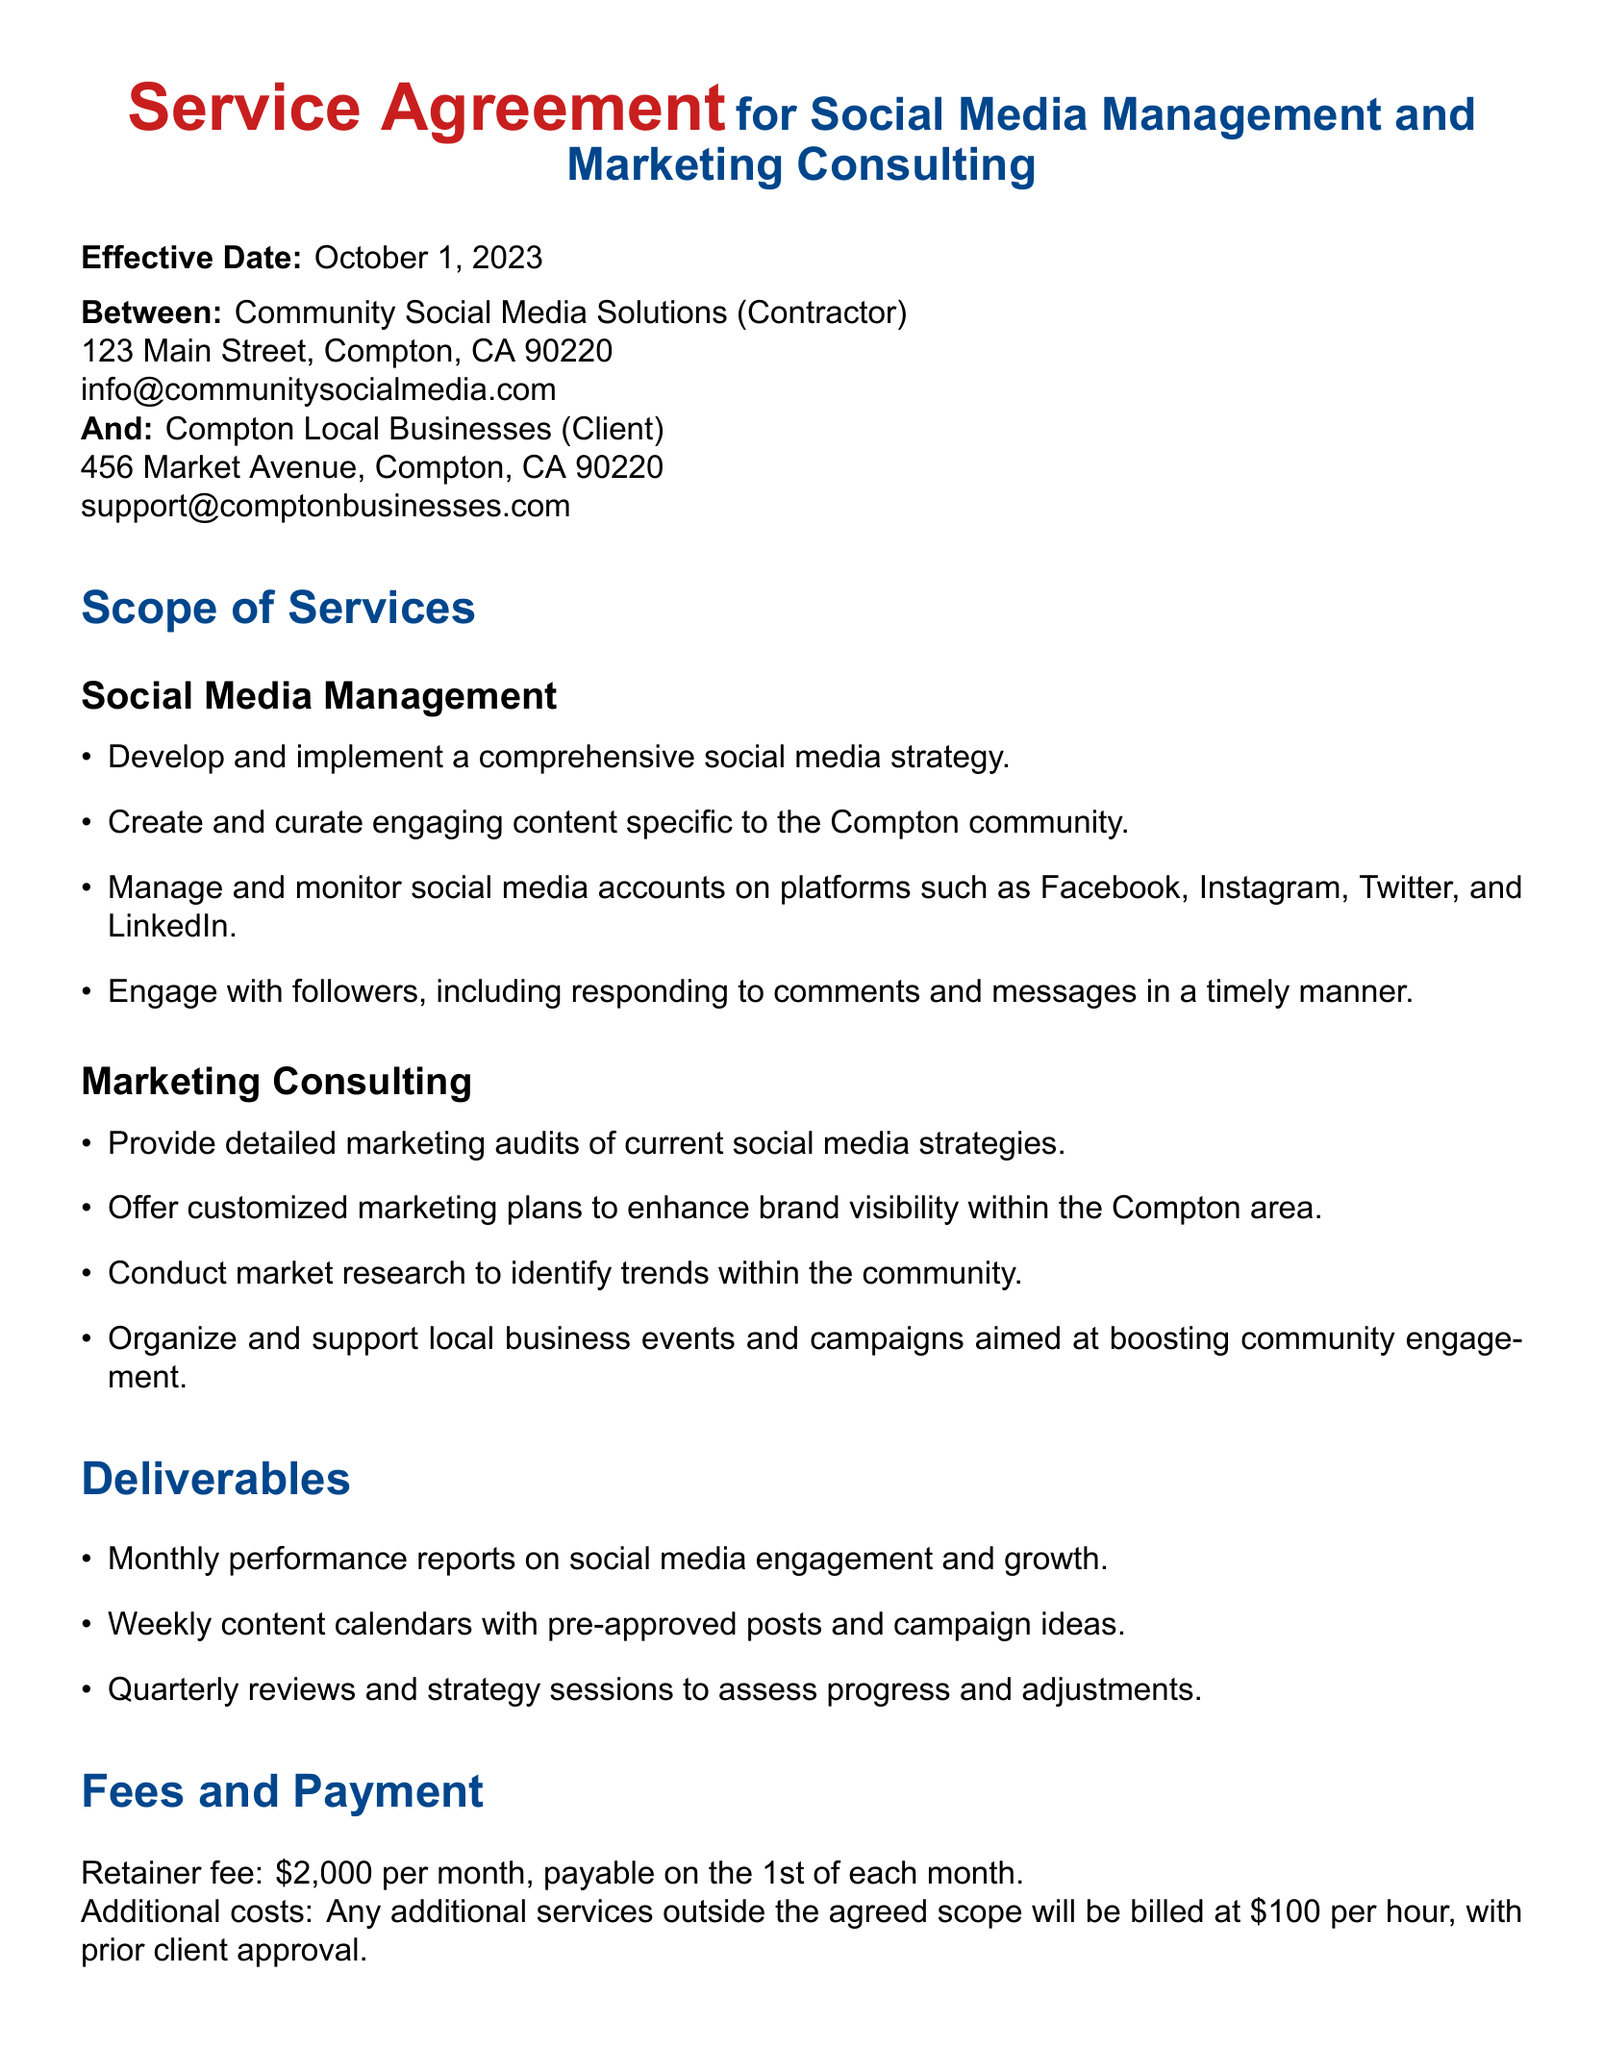What is the effective date of the service agreement? The effective date is provided in the document as the start date for the agreement.
Answer: October 1, 2023 Who is the contractor in this agreement? The contractor is the entity responsible for providing services as specified in the agreement.
Answer: Community Social Media Solutions What is the monthly retainer fee? The fee section specifies the amount the client needs to pay every month.
Answer: $2,000 How many days notice is required for termination? The termination clause states the amount of notice necessary for either party to terminate the agreement.
Answer: 30 days What type of content does the social media management service focus on? The scope of services outlines the focus of the social media strategy.
Answer: Compton community What are the deliverables mentioned in the document? Deliverables are specified for what the contractor will provide to the client throughout the engagement.
Answer: Monthly performance reports, Weekly content calendars, Quarterly reviews What happens upon termination of the agreement? The termination clause explains the responsibilities of the contractor upon ending the contract.
Answer: Final report and return materials What is the additional service cost per hour? Any additional services outside the agreed scope has a specified hourly rate as mentioned in the payment section.
Answer: $100 per hour What is one of the marketing consulting services provided? The marketing consulting section highlights activities that will enhance brand visibility, among other tasks.
Answer: Customized marketing plans 